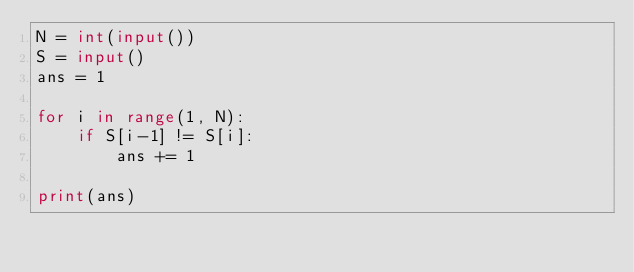Convert code to text. <code><loc_0><loc_0><loc_500><loc_500><_Python_>N = int(input())
S = input()
ans = 1

for i in range(1, N):
    if S[i-1] != S[i]:
        ans += 1

print(ans)</code> 